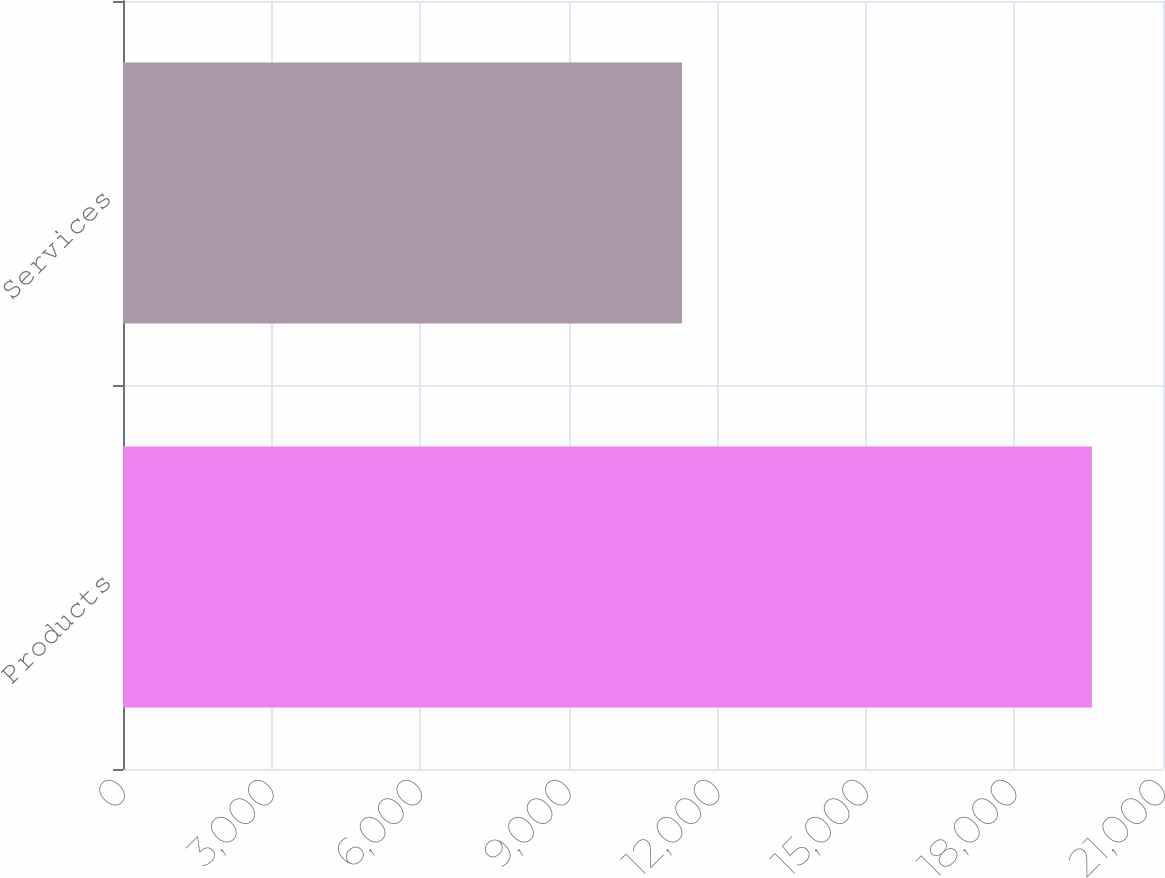Convert chart to OTSL. <chart><loc_0><loc_0><loc_500><loc_500><bar_chart><fcel>Products<fcel>Services<nl><fcel>19564<fcel>11288<nl></chart> 